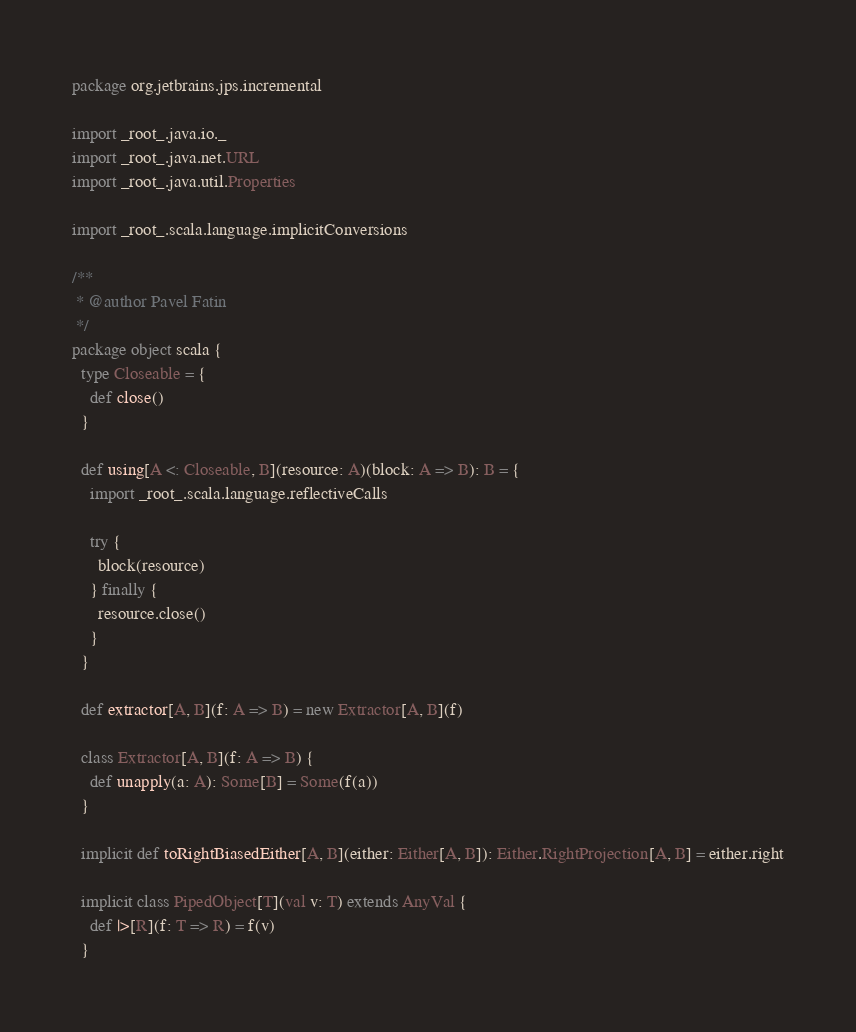<code> <loc_0><loc_0><loc_500><loc_500><_Scala_>package org.jetbrains.jps.incremental

import _root_.java.io._
import _root_.java.net.URL
import _root_.java.util.Properties

import _root_.scala.language.implicitConversions

/**
 * @author Pavel Fatin
 */
package object scala {
  type Closeable = {
    def close()
  }

  def using[A <: Closeable, B](resource: A)(block: A => B): B = {
    import _root_.scala.language.reflectiveCalls

    try {
      block(resource)
    } finally {
      resource.close()
    }
  }

  def extractor[A, B](f: A => B) = new Extractor[A, B](f)

  class Extractor[A, B](f: A => B) {
    def unapply(a: A): Some[B] = Some(f(a))
  }

  implicit def toRightBiasedEither[A, B](either: Either[A, B]): Either.RightProjection[A, B] = either.right

  implicit class PipedObject[T](val v: T) extends AnyVal {
    def |>[R](f: T => R) = f(v)
  }
</code> 